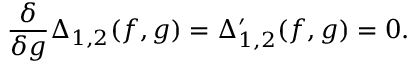<formula> <loc_0><loc_0><loc_500><loc_500>\frac { \delta } { \delta g } \Delta _ { 1 , 2 } ( f , g ) = \Delta _ { 1 , 2 } ^ { \prime } ( f , g ) = 0 .</formula> 